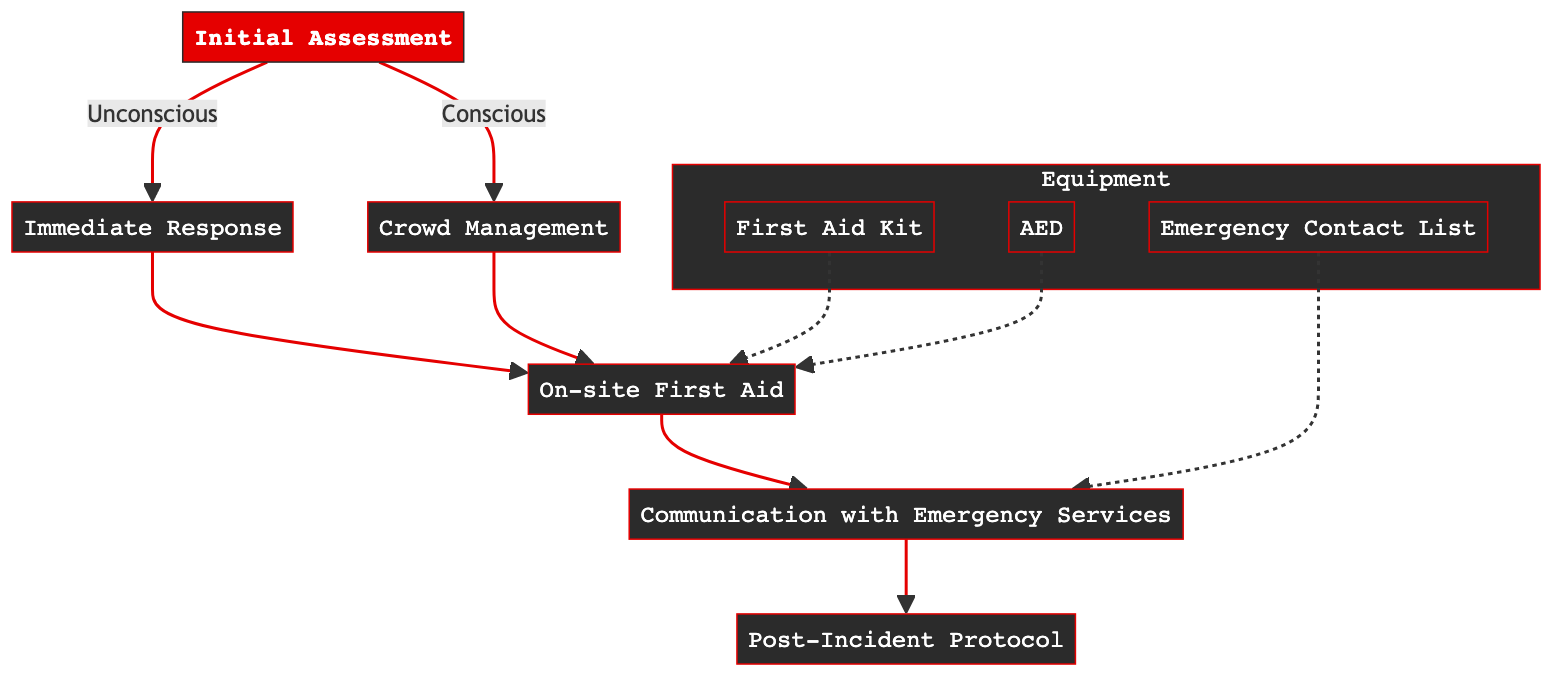What is the first step in the protocol? The first step in the protocol is "Initial Assessment." This is the starting point and the top node of the flowchart.
Answer: Initial Assessment How many response types are there after the initial assessment? After the initial assessment, there are two possible responses: "Immediate Response" for unconscious individuals and "Crowd Management" for conscious individuals. This counts as two pathways branching out from "Initial Assessment."
Answer: 2 Which action follows if the victim is unconscious? If the victim is unconscious, the immediate action taken is to "call 911 immediately," which leads directly from the "Immediate Response" node.
Answer: Call 911 What type of equipment is required for on-site first aid? The equipment needed for on-site first aid includes the "First Aid Kit" and "AED." These are located near the response actions designated for first aid in the diagram.
Answer: First Aid Kit, AED What leads to communication with emergency services? Communication with emergency services is prompted after on-site first aid actions have been taken (from the "On-site First Aid" node), regardless of whether it originated from "Immediate Response" or "Crowd Management."
Answer: On-site First Aid How should the band manage the audience if a medical issue occurs? The band should direct the audience away from the stage, ensuring calm and clear exit paths if necessary, as indicated in the "Crowd Management" section.
Answer: Direct audience away What is included in the post-incident protocol? The post-incident protocol includes documenting the incident, notifying venue management, and following up on the victim's condition to provide support. These are the key components listed under "Post-Incident Protocol."
Answer: Document incident, notify management, follow up Where is the First Aid Kit located? The First Aid Kit is specifically located backstage near the sound equipment, as indicated in the "Equipment and Resources" section of the diagram.
Answer: Backstage near sound equipment Which node involves describing the victim's condition? Describing the victim's condition is part of the "Communication with Emergency Services" node, as detail towards the victim's state is necessary during the communication.
Answer: Communication with Emergency Services What must be documented after the incident? After the incident, it is necessary to document the time, response actions taken, and the victim's condition, as detailed in the "Post-Incident Protocol" section.
Answer: Time, response actions, condition 